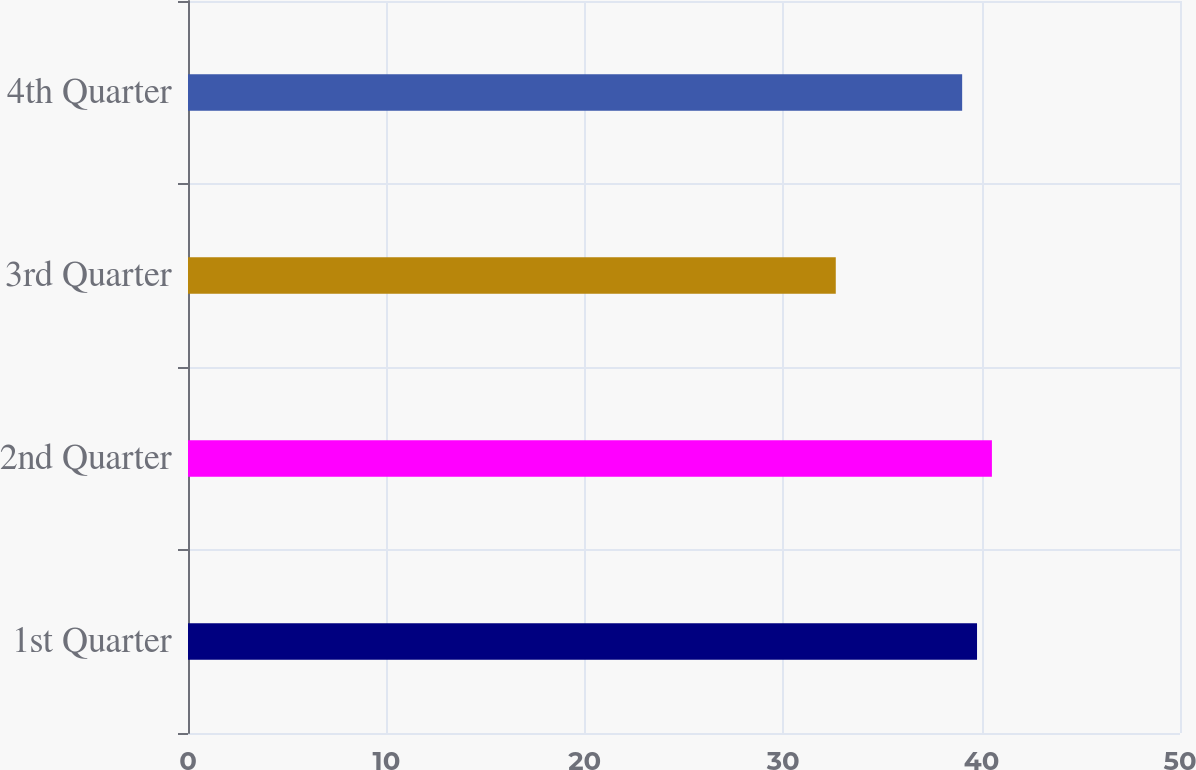<chart> <loc_0><loc_0><loc_500><loc_500><bar_chart><fcel>1st Quarter<fcel>2nd Quarter<fcel>3rd Quarter<fcel>4th Quarter<nl><fcel>39.77<fcel>40.52<fcel>32.65<fcel>39.02<nl></chart> 